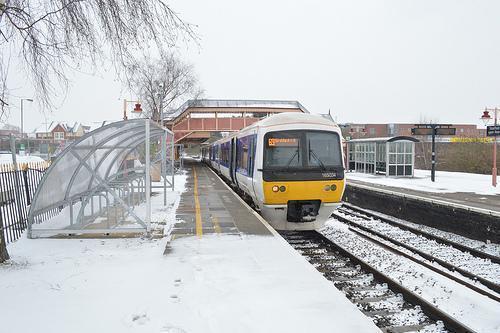How many trains are there?
Give a very brief answer. 1. 